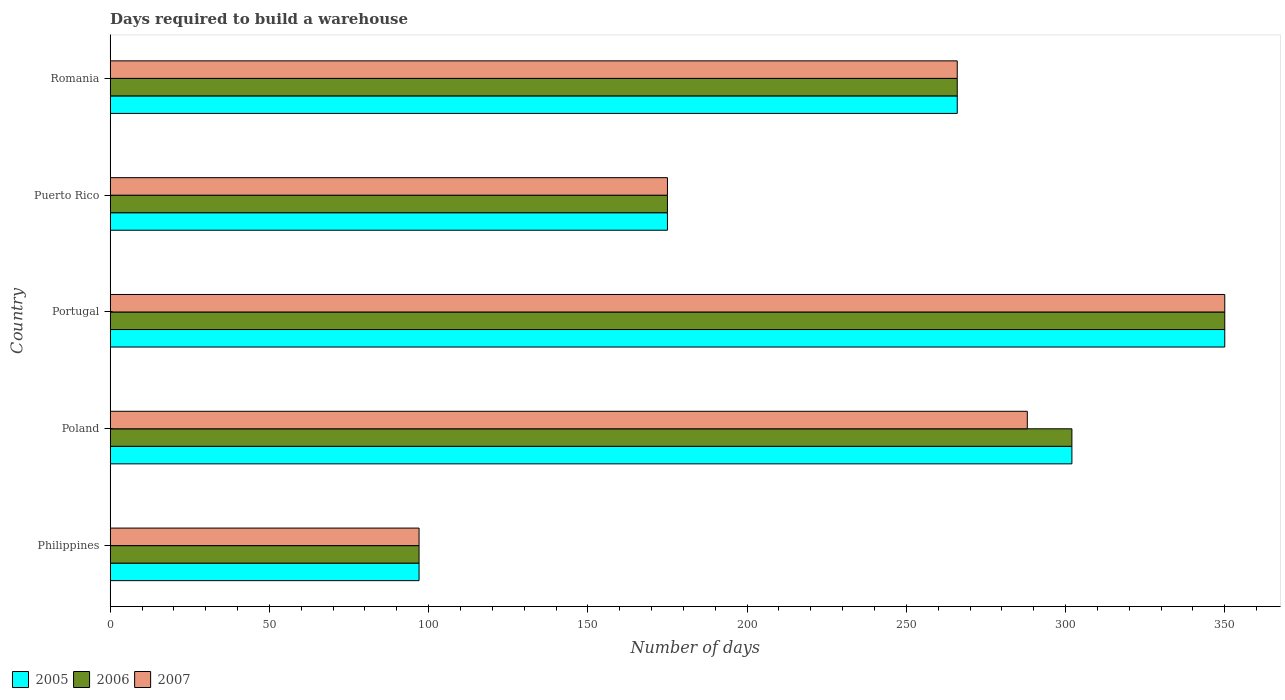Are the number of bars on each tick of the Y-axis equal?
Keep it short and to the point. Yes. How many bars are there on the 2nd tick from the top?
Keep it short and to the point. 3. What is the label of the 3rd group of bars from the top?
Ensure brevity in your answer.  Portugal. In how many cases, is the number of bars for a given country not equal to the number of legend labels?
Keep it short and to the point. 0. What is the days required to build a warehouse in in 2006 in Puerto Rico?
Provide a short and direct response. 175. Across all countries, what is the maximum days required to build a warehouse in in 2005?
Your response must be concise. 350. Across all countries, what is the minimum days required to build a warehouse in in 2006?
Give a very brief answer. 97. What is the total days required to build a warehouse in in 2006 in the graph?
Your answer should be very brief. 1190. What is the difference between the days required to build a warehouse in in 2005 in Poland and that in Puerto Rico?
Make the answer very short. 127. What is the difference between the days required to build a warehouse in in 2005 in Poland and the days required to build a warehouse in in 2006 in Portugal?
Ensure brevity in your answer.  -48. What is the average days required to build a warehouse in in 2006 per country?
Ensure brevity in your answer.  238. What is the ratio of the days required to build a warehouse in in 2005 in Poland to that in Portugal?
Offer a very short reply. 0.86. Is the days required to build a warehouse in in 2007 in Philippines less than that in Puerto Rico?
Provide a short and direct response. Yes. What is the difference between the highest and the second highest days required to build a warehouse in in 2005?
Offer a terse response. 48. What is the difference between the highest and the lowest days required to build a warehouse in in 2006?
Offer a terse response. 253. In how many countries, is the days required to build a warehouse in in 2005 greater than the average days required to build a warehouse in in 2005 taken over all countries?
Your answer should be very brief. 3. Is the sum of the days required to build a warehouse in in 2005 in Poland and Puerto Rico greater than the maximum days required to build a warehouse in in 2006 across all countries?
Offer a terse response. Yes. What does the 2nd bar from the top in Romania represents?
Make the answer very short. 2006. Is it the case that in every country, the sum of the days required to build a warehouse in in 2005 and days required to build a warehouse in in 2006 is greater than the days required to build a warehouse in in 2007?
Your answer should be very brief. Yes. What is the difference between two consecutive major ticks on the X-axis?
Provide a succinct answer. 50. Are the values on the major ticks of X-axis written in scientific E-notation?
Keep it short and to the point. No. How are the legend labels stacked?
Ensure brevity in your answer.  Horizontal. What is the title of the graph?
Your response must be concise. Days required to build a warehouse. What is the label or title of the X-axis?
Offer a very short reply. Number of days. What is the Number of days of 2005 in Philippines?
Provide a succinct answer. 97. What is the Number of days of 2006 in Philippines?
Offer a terse response. 97. What is the Number of days in 2007 in Philippines?
Offer a very short reply. 97. What is the Number of days of 2005 in Poland?
Provide a short and direct response. 302. What is the Number of days in 2006 in Poland?
Ensure brevity in your answer.  302. What is the Number of days in 2007 in Poland?
Give a very brief answer. 288. What is the Number of days of 2005 in Portugal?
Provide a succinct answer. 350. What is the Number of days in 2006 in Portugal?
Keep it short and to the point. 350. What is the Number of days in 2007 in Portugal?
Ensure brevity in your answer.  350. What is the Number of days in 2005 in Puerto Rico?
Your answer should be compact. 175. What is the Number of days in 2006 in Puerto Rico?
Ensure brevity in your answer.  175. What is the Number of days in 2007 in Puerto Rico?
Provide a short and direct response. 175. What is the Number of days of 2005 in Romania?
Provide a short and direct response. 266. What is the Number of days of 2006 in Romania?
Your answer should be very brief. 266. What is the Number of days in 2007 in Romania?
Ensure brevity in your answer.  266. Across all countries, what is the maximum Number of days in 2005?
Your response must be concise. 350. Across all countries, what is the maximum Number of days of 2006?
Your answer should be very brief. 350. Across all countries, what is the maximum Number of days in 2007?
Ensure brevity in your answer.  350. Across all countries, what is the minimum Number of days of 2005?
Your answer should be very brief. 97. Across all countries, what is the minimum Number of days of 2006?
Offer a terse response. 97. Across all countries, what is the minimum Number of days in 2007?
Ensure brevity in your answer.  97. What is the total Number of days of 2005 in the graph?
Your answer should be very brief. 1190. What is the total Number of days in 2006 in the graph?
Your answer should be compact. 1190. What is the total Number of days in 2007 in the graph?
Provide a succinct answer. 1176. What is the difference between the Number of days in 2005 in Philippines and that in Poland?
Give a very brief answer. -205. What is the difference between the Number of days of 2006 in Philippines and that in Poland?
Provide a short and direct response. -205. What is the difference between the Number of days in 2007 in Philippines and that in Poland?
Ensure brevity in your answer.  -191. What is the difference between the Number of days in 2005 in Philippines and that in Portugal?
Offer a very short reply. -253. What is the difference between the Number of days in 2006 in Philippines and that in Portugal?
Offer a terse response. -253. What is the difference between the Number of days of 2007 in Philippines and that in Portugal?
Provide a succinct answer. -253. What is the difference between the Number of days of 2005 in Philippines and that in Puerto Rico?
Ensure brevity in your answer.  -78. What is the difference between the Number of days in 2006 in Philippines and that in Puerto Rico?
Offer a very short reply. -78. What is the difference between the Number of days of 2007 in Philippines and that in Puerto Rico?
Make the answer very short. -78. What is the difference between the Number of days in 2005 in Philippines and that in Romania?
Ensure brevity in your answer.  -169. What is the difference between the Number of days of 2006 in Philippines and that in Romania?
Ensure brevity in your answer.  -169. What is the difference between the Number of days in 2007 in Philippines and that in Romania?
Provide a succinct answer. -169. What is the difference between the Number of days in 2005 in Poland and that in Portugal?
Your answer should be very brief. -48. What is the difference between the Number of days of 2006 in Poland and that in Portugal?
Offer a terse response. -48. What is the difference between the Number of days in 2007 in Poland and that in Portugal?
Provide a succinct answer. -62. What is the difference between the Number of days of 2005 in Poland and that in Puerto Rico?
Offer a very short reply. 127. What is the difference between the Number of days of 2006 in Poland and that in Puerto Rico?
Ensure brevity in your answer.  127. What is the difference between the Number of days in 2007 in Poland and that in Puerto Rico?
Your answer should be very brief. 113. What is the difference between the Number of days in 2006 in Poland and that in Romania?
Provide a succinct answer. 36. What is the difference between the Number of days in 2005 in Portugal and that in Puerto Rico?
Make the answer very short. 175. What is the difference between the Number of days of 2006 in Portugal and that in Puerto Rico?
Give a very brief answer. 175. What is the difference between the Number of days in 2007 in Portugal and that in Puerto Rico?
Make the answer very short. 175. What is the difference between the Number of days of 2005 in Puerto Rico and that in Romania?
Provide a succinct answer. -91. What is the difference between the Number of days of 2006 in Puerto Rico and that in Romania?
Your answer should be very brief. -91. What is the difference between the Number of days in 2007 in Puerto Rico and that in Romania?
Give a very brief answer. -91. What is the difference between the Number of days of 2005 in Philippines and the Number of days of 2006 in Poland?
Your answer should be compact. -205. What is the difference between the Number of days in 2005 in Philippines and the Number of days in 2007 in Poland?
Provide a short and direct response. -191. What is the difference between the Number of days in 2006 in Philippines and the Number of days in 2007 in Poland?
Keep it short and to the point. -191. What is the difference between the Number of days in 2005 in Philippines and the Number of days in 2006 in Portugal?
Give a very brief answer. -253. What is the difference between the Number of days of 2005 in Philippines and the Number of days of 2007 in Portugal?
Provide a short and direct response. -253. What is the difference between the Number of days of 2006 in Philippines and the Number of days of 2007 in Portugal?
Keep it short and to the point. -253. What is the difference between the Number of days of 2005 in Philippines and the Number of days of 2006 in Puerto Rico?
Offer a terse response. -78. What is the difference between the Number of days of 2005 in Philippines and the Number of days of 2007 in Puerto Rico?
Give a very brief answer. -78. What is the difference between the Number of days of 2006 in Philippines and the Number of days of 2007 in Puerto Rico?
Your answer should be very brief. -78. What is the difference between the Number of days of 2005 in Philippines and the Number of days of 2006 in Romania?
Provide a succinct answer. -169. What is the difference between the Number of days in 2005 in Philippines and the Number of days in 2007 in Romania?
Provide a short and direct response. -169. What is the difference between the Number of days of 2006 in Philippines and the Number of days of 2007 in Romania?
Provide a succinct answer. -169. What is the difference between the Number of days in 2005 in Poland and the Number of days in 2006 in Portugal?
Offer a terse response. -48. What is the difference between the Number of days in 2005 in Poland and the Number of days in 2007 in Portugal?
Your answer should be compact. -48. What is the difference between the Number of days in 2006 in Poland and the Number of days in 2007 in Portugal?
Your answer should be compact. -48. What is the difference between the Number of days in 2005 in Poland and the Number of days in 2006 in Puerto Rico?
Make the answer very short. 127. What is the difference between the Number of days of 2005 in Poland and the Number of days of 2007 in Puerto Rico?
Provide a succinct answer. 127. What is the difference between the Number of days of 2006 in Poland and the Number of days of 2007 in Puerto Rico?
Keep it short and to the point. 127. What is the difference between the Number of days of 2005 in Poland and the Number of days of 2006 in Romania?
Provide a short and direct response. 36. What is the difference between the Number of days in 2005 in Poland and the Number of days in 2007 in Romania?
Your response must be concise. 36. What is the difference between the Number of days of 2005 in Portugal and the Number of days of 2006 in Puerto Rico?
Offer a very short reply. 175. What is the difference between the Number of days of 2005 in Portugal and the Number of days of 2007 in Puerto Rico?
Your answer should be compact. 175. What is the difference between the Number of days in 2006 in Portugal and the Number of days in 2007 in Puerto Rico?
Ensure brevity in your answer.  175. What is the difference between the Number of days of 2006 in Portugal and the Number of days of 2007 in Romania?
Offer a terse response. 84. What is the difference between the Number of days in 2005 in Puerto Rico and the Number of days in 2006 in Romania?
Offer a terse response. -91. What is the difference between the Number of days in 2005 in Puerto Rico and the Number of days in 2007 in Romania?
Keep it short and to the point. -91. What is the difference between the Number of days of 2006 in Puerto Rico and the Number of days of 2007 in Romania?
Your response must be concise. -91. What is the average Number of days of 2005 per country?
Your response must be concise. 238. What is the average Number of days of 2006 per country?
Your answer should be very brief. 238. What is the average Number of days of 2007 per country?
Keep it short and to the point. 235.2. What is the difference between the Number of days in 2005 and Number of days in 2006 in Philippines?
Offer a very short reply. 0. What is the difference between the Number of days in 2005 and Number of days in 2007 in Philippines?
Make the answer very short. 0. What is the difference between the Number of days in 2006 and Number of days in 2007 in Philippines?
Offer a very short reply. 0. What is the difference between the Number of days of 2005 and Number of days of 2007 in Poland?
Keep it short and to the point. 14. What is the difference between the Number of days in 2005 and Number of days in 2006 in Portugal?
Give a very brief answer. 0. What is the difference between the Number of days in 2005 and Number of days in 2007 in Portugal?
Keep it short and to the point. 0. What is the difference between the Number of days in 2006 and Number of days in 2007 in Portugal?
Provide a succinct answer. 0. What is the difference between the Number of days of 2005 and Number of days of 2006 in Puerto Rico?
Offer a terse response. 0. What is the difference between the Number of days of 2005 and Number of days of 2007 in Puerto Rico?
Make the answer very short. 0. What is the difference between the Number of days in 2006 and Number of days in 2007 in Puerto Rico?
Offer a very short reply. 0. What is the difference between the Number of days of 2005 and Number of days of 2006 in Romania?
Your answer should be compact. 0. What is the difference between the Number of days in 2005 and Number of days in 2007 in Romania?
Your response must be concise. 0. What is the difference between the Number of days of 2006 and Number of days of 2007 in Romania?
Your answer should be compact. 0. What is the ratio of the Number of days in 2005 in Philippines to that in Poland?
Give a very brief answer. 0.32. What is the ratio of the Number of days of 2006 in Philippines to that in Poland?
Keep it short and to the point. 0.32. What is the ratio of the Number of days of 2007 in Philippines to that in Poland?
Your answer should be very brief. 0.34. What is the ratio of the Number of days in 2005 in Philippines to that in Portugal?
Your answer should be very brief. 0.28. What is the ratio of the Number of days in 2006 in Philippines to that in Portugal?
Provide a short and direct response. 0.28. What is the ratio of the Number of days of 2007 in Philippines to that in Portugal?
Make the answer very short. 0.28. What is the ratio of the Number of days of 2005 in Philippines to that in Puerto Rico?
Your answer should be very brief. 0.55. What is the ratio of the Number of days of 2006 in Philippines to that in Puerto Rico?
Your answer should be compact. 0.55. What is the ratio of the Number of days in 2007 in Philippines to that in Puerto Rico?
Your answer should be very brief. 0.55. What is the ratio of the Number of days in 2005 in Philippines to that in Romania?
Give a very brief answer. 0.36. What is the ratio of the Number of days of 2006 in Philippines to that in Romania?
Your answer should be compact. 0.36. What is the ratio of the Number of days in 2007 in Philippines to that in Romania?
Your answer should be compact. 0.36. What is the ratio of the Number of days of 2005 in Poland to that in Portugal?
Your answer should be compact. 0.86. What is the ratio of the Number of days in 2006 in Poland to that in Portugal?
Provide a succinct answer. 0.86. What is the ratio of the Number of days of 2007 in Poland to that in Portugal?
Your answer should be compact. 0.82. What is the ratio of the Number of days of 2005 in Poland to that in Puerto Rico?
Offer a very short reply. 1.73. What is the ratio of the Number of days in 2006 in Poland to that in Puerto Rico?
Provide a short and direct response. 1.73. What is the ratio of the Number of days in 2007 in Poland to that in Puerto Rico?
Offer a terse response. 1.65. What is the ratio of the Number of days of 2005 in Poland to that in Romania?
Offer a very short reply. 1.14. What is the ratio of the Number of days of 2006 in Poland to that in Romania?
Provide a short and direct response. 1.14. What is the ratio of the Number of days of 2007 in Poland to that in Romania?
Make the answer very short. 1.08. What is the ratio of the Number of days in 2006 in Portugal to that in Puerto Rico?
Your answer should be very brief. 2. What is the ratio of the Number of days of 2005 in Portugal to that in Romania?
Offer a terse response. 1.32. What is the ratio of the Number of days of 2006 in Portugal to that in Romania?
Your answer should be compact. 1.32. What is the ratio of the Number of days of 2007 in Portugal to that in Romania?
Your answer should be compact. 1.32. What is the ratio of the Number of days in 2005 in Puerto Rico to that in Romania?
Provide a short and direct response. 0.66. What is the ratio of the Number of days in 2006 in Puerto Rico to that in Romania?
Make the answer very short. 0.66. What is the ratio of the Number of days of 2007 in Puerto Rico to that in Romania?
Keep it short and to the point. 0.66. What is the difference between the highest and the second highest Number of days in 2006?
Keep it short and to the point. 48. What is the difference between the highest and the second highest Number of days of 2007?
Keep it short and to the point. 62. What is the difference between the highest and the lowest Number of days of 2005?
Offer a very short reply. 253. What is the difference between the highest and the lowest Number of days in 2006?
Your answer should be very brief. 253. What is the difference between the highest and the lowest Number of days in 2007?
Keep it short and to the point. 253. 